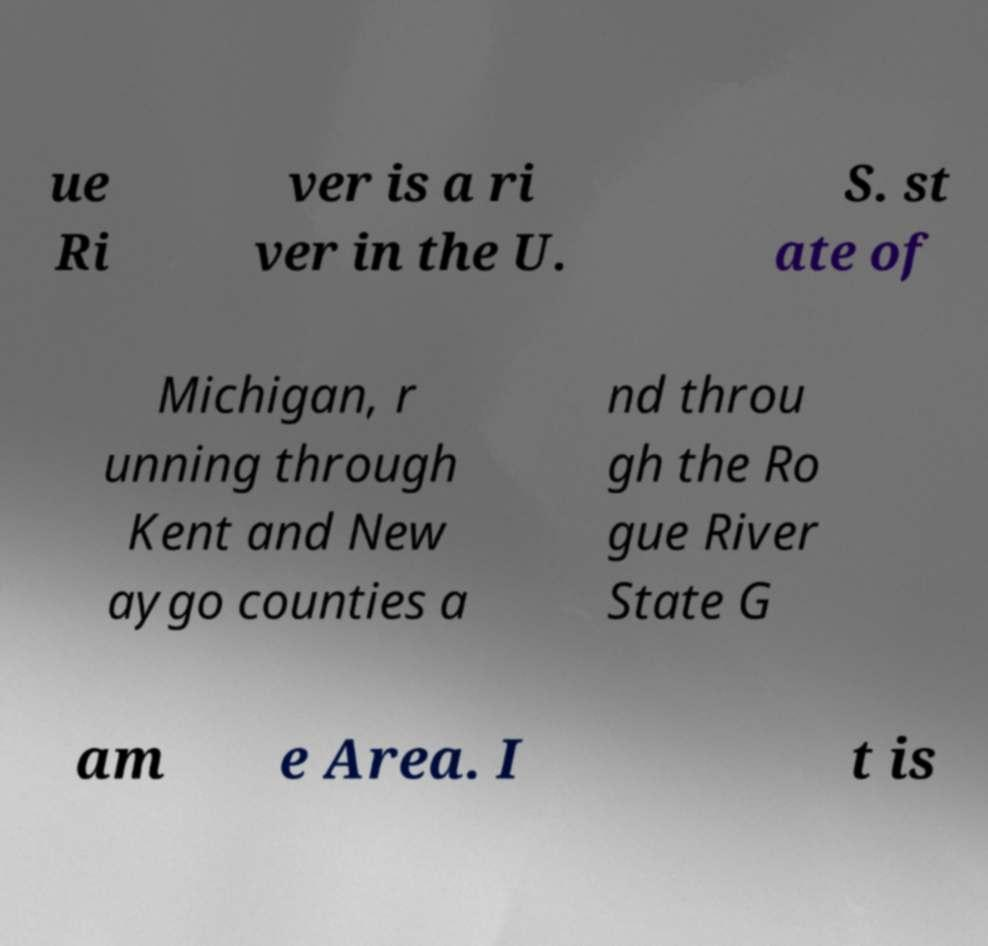Can you read and provide the text displayed in the image?This photo seems to have some interesting text. Can you extract and type it out for me? ue Ri ver is a ri ver in the U. S. st ate of Michigan, r unning through Kent and New aygo counties a nd throu gh the Ro gue River State G am e Area. I t is 